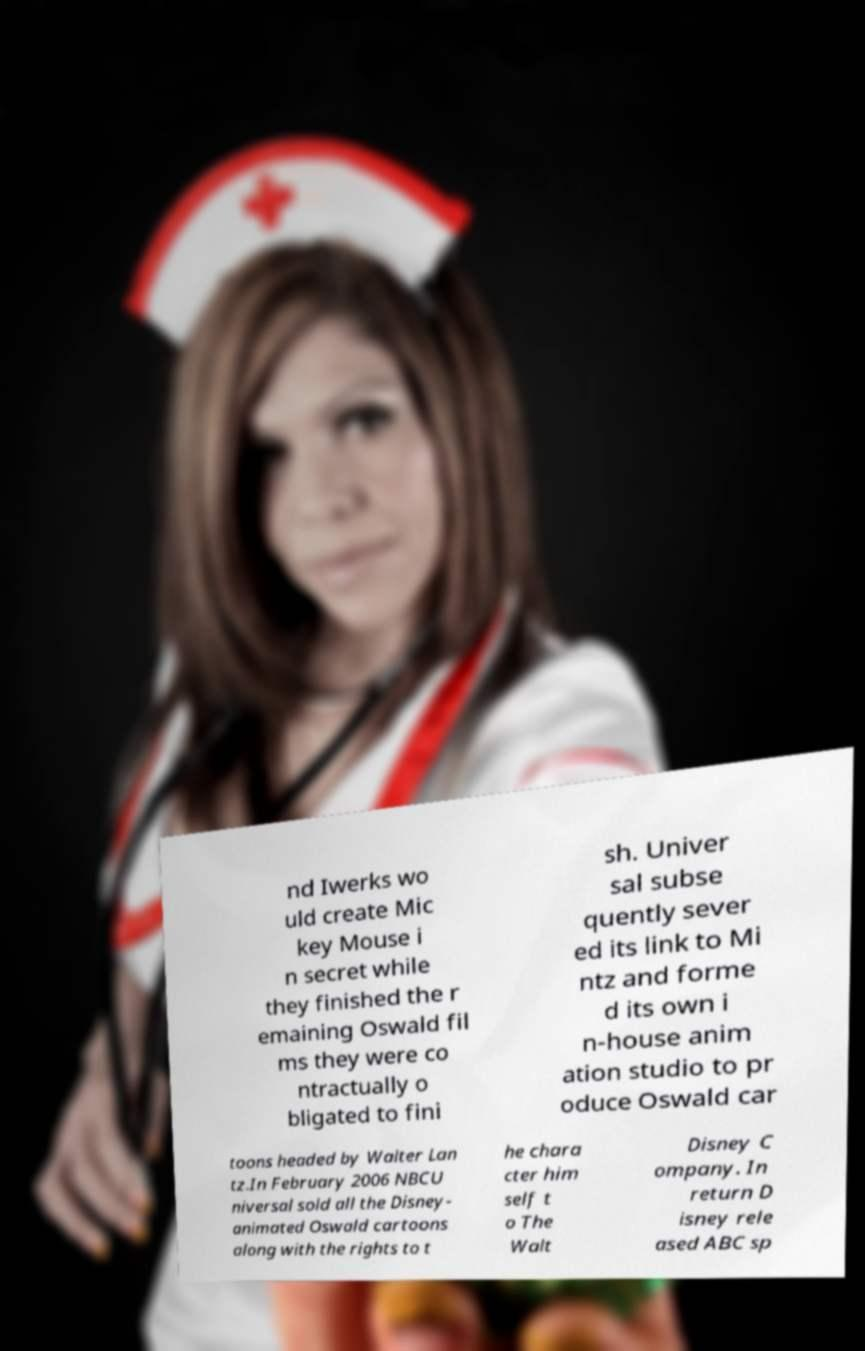I need the written content from this picture converted into text. Can you do that? nd Iwerks wo uld create Mic key Mouse i n secret while they finished the r emaining Oswald fil ms they were co ntractually o bligated to fini sh. Univer sal subse quently sever ed its link to Mi ntz and forme d its own i n-house anim ation studio to pr oduce Oswald car toons headed by Walter Lan tz.In February 2006 NBCU niversal sold all the Disney- animated Oswald cartoons along with the rights to t he chara cter him self t o The Walt Disney C ompany. In return D isney rele ased ABC sp 